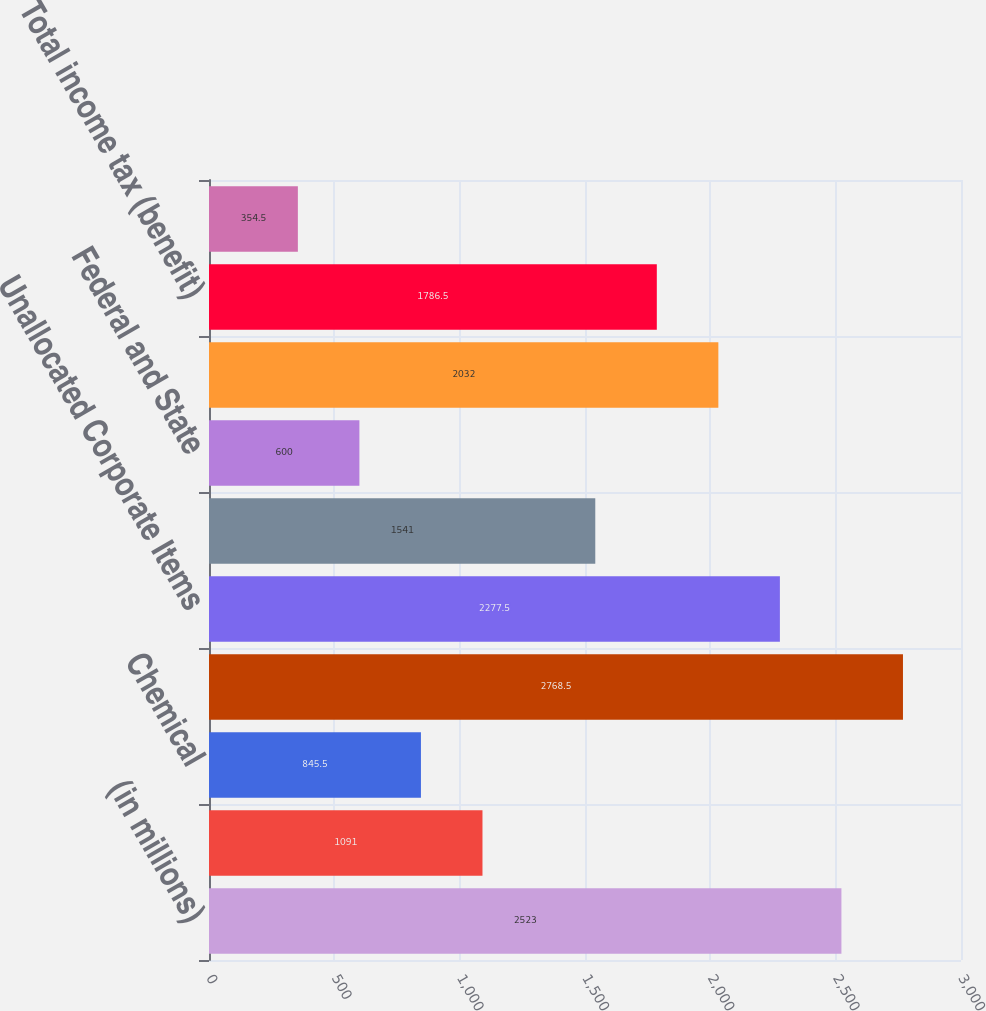Convert chart to OTSL. <chart><loc_0><loc_0><loc_500><loc_500><bar_chart><fcel>(in millions)<fcel>Oil and Gas<fcel>Chemical<fcel>Midstream and Marketing (a)<fcel>Unallocated Corporate Items<fcel>Pre-tax (loss) income<fcel>Federal and State<fcel>Foreign<fcel>Total income tax (benefit)<fcel>Income (loss) from continuing<nl><fcel>2523<fcel>1091<fcel>845.5<fcel>2768.5<fcel>2277.5<fcel>1541<fcel>600<fcel>2032<fcel>1786.5<fcel>354.5<nl></chart> 